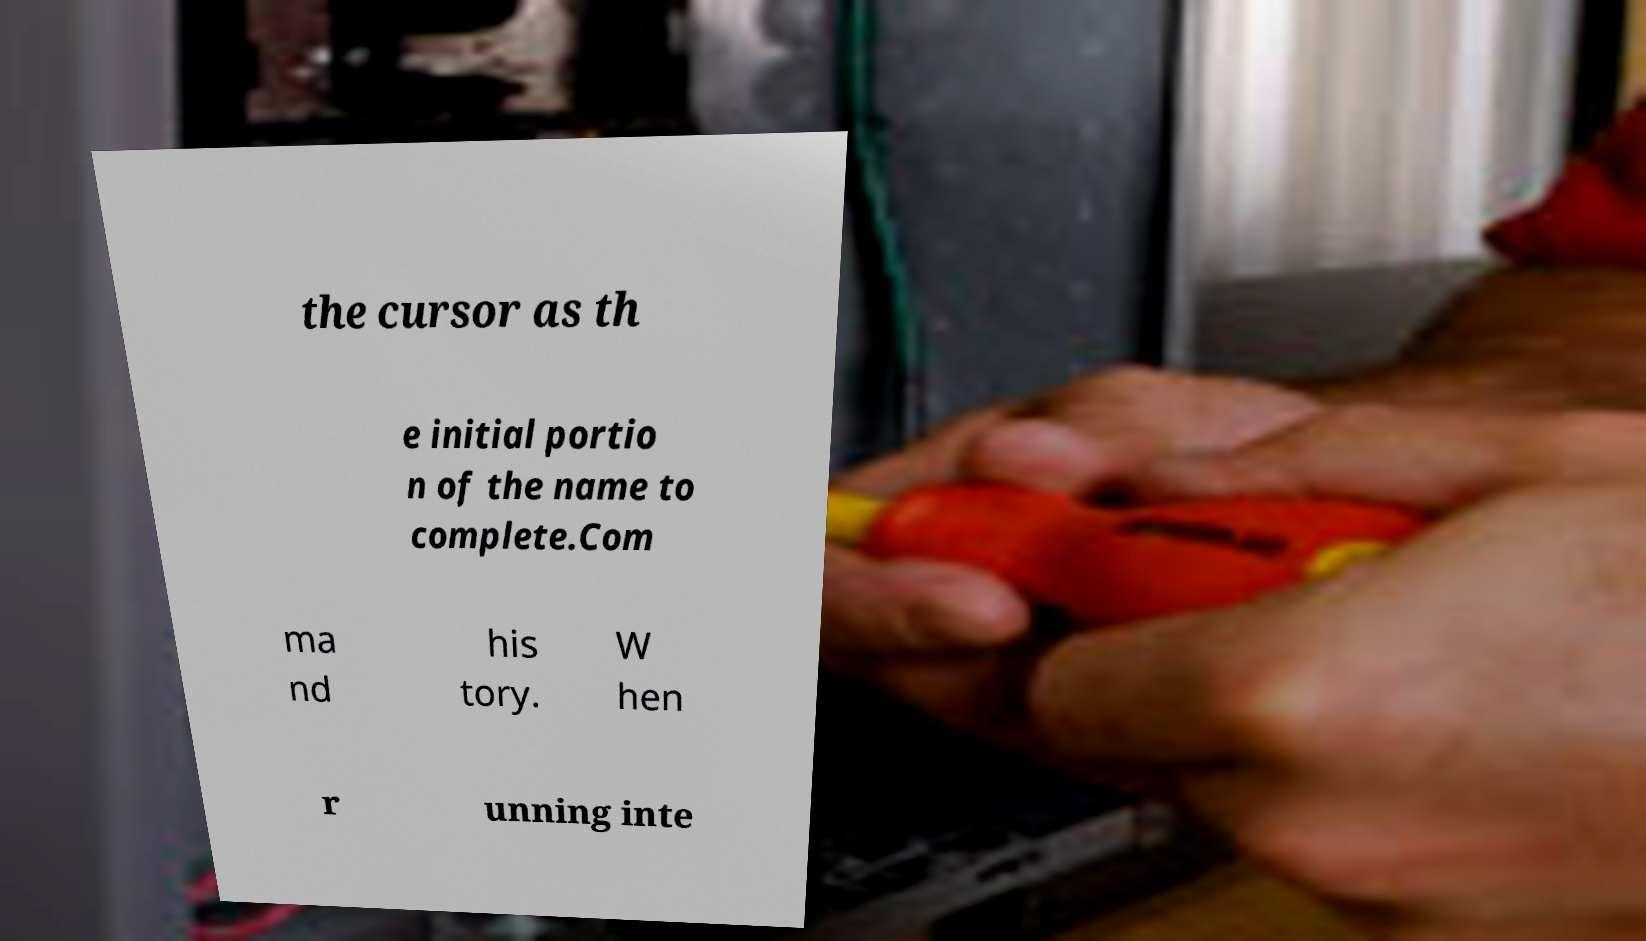Can you accurately transcribe the text from the provided image for me? the cursor as th e initial portio n of the name to complete.Com ma nd his tory. W hen r unning inte 